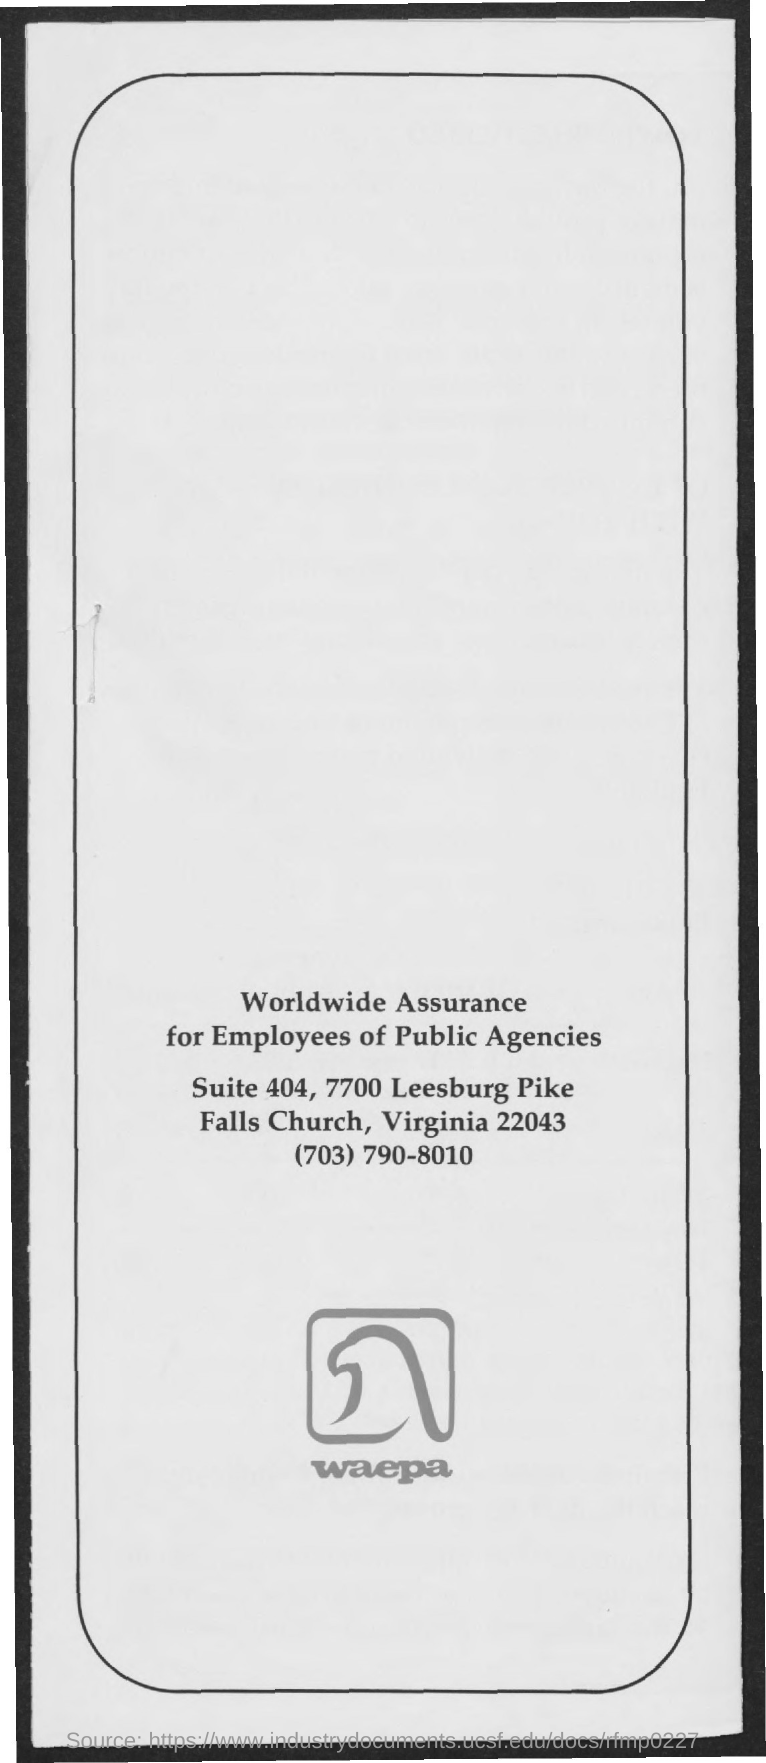What is written below the logo ?
Provide a short and direct response. WAEPA. 